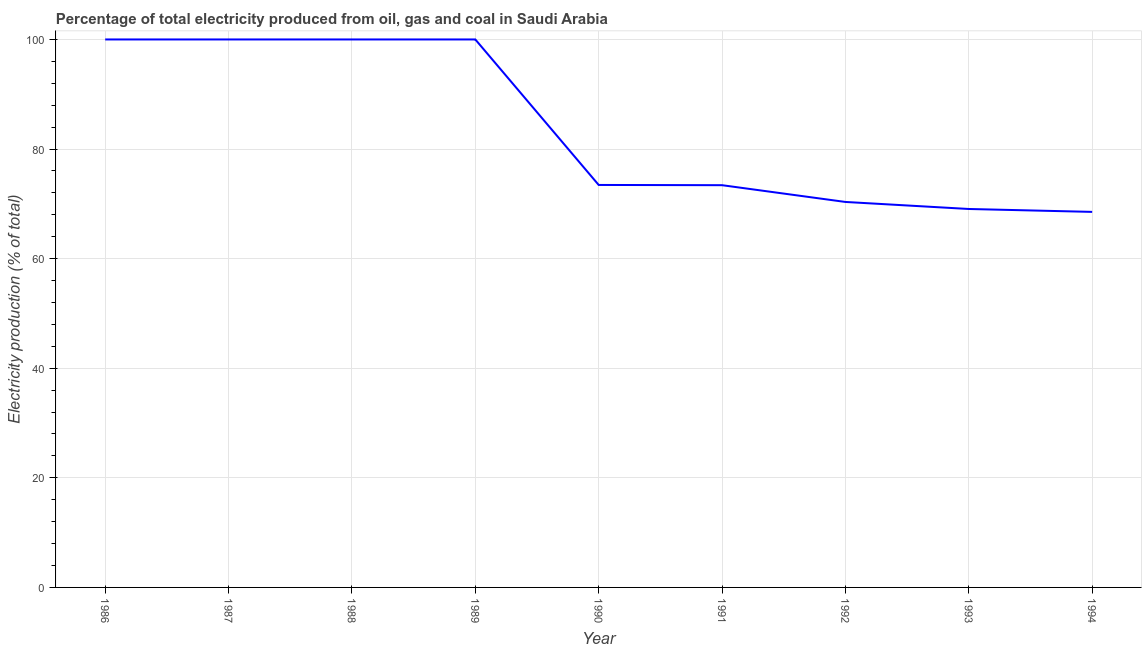What is the electricity production in 1989?
Ensure brevity in your answer.  100. Across all years, what is the maximum electricity production?
Offer a very short reply. 100. Across all years, what is the minimum electricity production?
Keep it short and to the point. 68.53. In which year was the electricity production maximum?
Provide a short and direct response. 1986. In which year was the electricity production minimum?
Provide a short and direct response. 1994. What is the sum of the electricity production?
Your answer should be very brief. 754.79. What is the difference between the electricity production in 1989 and 1993?
Provide a succinct answer. 30.94. What is the average electricity production per year?
Your answer should be very brief. 83.87. What is the median electricity production?
Offer a terse response. 73.45. In how many years, is the electricity production greater than 8 %?
Provide a short and direct response. 9. What is the ratio of the electricity production in 1989 to that in 1991?
Your response must be concise. 1.36. Is the difference between the electricity production in 1987 and 1992 greater than the difference between any two years?
Offer a very short reply. No. What is the difference between the highest and the lowest electricity production?
Your answer should be very brief. 31.47. In how many years, is the electricity production greater than the average electricity production taken over all years?
Offer a very short reply. 4. Does the electricity production monotonically increase over the years?
Ensure brevity in your answer.  No. How many lines are there?
Keep it short and to the point. 1. How many years are there in the graph?
Provide a short and direct response. 9. Does the graph contain any zero values?
Make the answer very short. No. Does the graph contain grids?
Your answer should be compact. Yes. What is the title of the graph?
Make the answer very short. Percentage of total electricity produced from oil, gas and coal in Saudi Arabia. What is the label or title of the Y-axis?
Your answer should be very brief. Electricity production (% of total). What is the Electricity production (% of total) of 1990?
Your answer should be very brief. 73.45. What is the Electricity production (% of total) of 1991?
Provide a short and direct response. 73.4. What is the Electricity production (% of total) in 1992?
Make the answer very short. 70.34. What is the Electricity production (% of total) of 1993?
Provide a short and direct response. 69.06. What is the Electricity production (% of total) of 1994?
Provide a short and direct response. 68.53. What is the difference between the Electricity production (% of total) in 1986 and 1987?
Ensure brevity in your answer.  0. What is the difference between the Electricity production (% of total) in 1986 and 1990?
Keep it short and to the point. 26.55. What is the difference between the Electricity production (% of total) in 1986 and 1991?
Offer a very short reply. 26.6. What is the difference between the Electricity production (% of total) in 1986 and 1992?
Keep it short and to the point. 29.66. What is the difference between the Electricity production (% of total) in 1986 and 1993?
Ensure brevity in your answer.  30.94. What is the difference between the Electricity production (% of total) in 1986 and 1994?
Your answer should be very brief. 31.47. What is the difference between the Electricity production (% of total) in 1987 and 1990?
Your answer should be very brief. 26.55. What is the difference between the Electricity production (% of total) in 1987 and 1991?
Ensure brevity in your answer.  26.6. What is the difference between the Electricity production (% of total) in 1987 and 1992?
Ensure brevity in your answer.  29.66. What is the difference between the Electricity production (% of total) in 1987 and 1993?
Keep it short and to the point. 30.94. What is the difference between the Electricity production (% of total) in 1987 and 1994?
Give a very brief answer. 31.47. What is the difference between the Electricity production (% of total) in 1988 and 1989?
Offer a terse response. 0. What is the difference between the Electricity production (% of total) in 1988 and 1990?
Give a very brief answer. 26.55. What is the difference between the Electricity production (% of total) in 1988 and 1991?
Offer a terse response. 26.6. What is the difference between the Electricity production (% of total) in 1988 and 1992?
Your answer should be very brief. 29.66. What is the difference between the Electricity production (% of total) in 1988 and 1993?
Provide a short and direct response. 30.94. What is the difference between the Electricity production (% of total) in 1988 and 1994?
Give a very brief answer. 31.47. What is the difference between the Electricity production (% of total) in 1989 and 1990?
Keep it short and to the point. 26.55. What is the difference between the Electricity production (% of total) in 1989 and 1991?
Provide a short and direct response. 26.6. What is the difference between the Electricity production (% of total) in 1989 and 1992?
Your answer should be compact. 29.66. What is the difference between the Electricity production (% of total) in 1989 and 1993?
Your answer should be compact. 30.94. What is the difference between the Electricity production (% of total) in 1989 and 1994?
Offer a terse response. 31.47. What is the difference between the Electricity production (% of total) in 1990 and 1991?
Ensure brevity in your answer.  0.04. What is the difference between the Electricity production (% of total) in 1990 and 1992?
Offer a very short reply. 3.1. What is the difference between the Electricity production (% of total) in 1990 and 1993?
Ensure brevity in your answer.  4.39. What is the difference between the Electricity production (% of total) in 1990 and 1994?
Your answer should be compact. 4.92. What is the difference between the Electricity production (% of total) in 1991 and 1992?
Ensure brevity in your answer.  3.06. What is the difference between the Electricity production (% of total) in 1991 and 1993?
Ensure brevity in your answer.  4.34. What is the difference between the Electricity production (% of total) in 1991 and 1994?
Provide a short and direct response. 4.87. What is the difference between the Electricity production (% of total) in 1992 and 1993?
Ensure brevity in your answer.  1.28. What is the difference between the Electricity production (% of total) in 1992 and 1994?
Your answer should be compact. 1.81. What is the difference between the Electricity production (% of total) in 1993 and 1994?
Offer a terse response. 0.53. What is the ratio of the Electricity production (% of total) in 1986 to that in 1987?
Your response must be concise. 1. What is the ratio of the Electricity production (% of total) in 1986 to that in 1989?
Ensure brevity in your answer.  1. What is the ratio of the Electricity production (% of total) in 1986 to that in 1990?
Give a very brief answer. 1.36. What is the ratio of the Electricity production (% of total) in 1986 to that in 1991?
Offer a terse response. 1.36. What is the ratio of the Electricity production (% of total) in 1986 to that in 1992?
Keep it short and to the point. 1.42. What is the ratio of the Electricity production (% of total) in 1986 to that in 1993?
Your answer should be very brief. 1.45. What is the ratio of the Electricity production (% of total) in 1986 to that in 1994?
Ensure brevity in your answer.  1.46. What is the ratio of the Electricity production (% of total) in 1987 to that in 1990?
Offer a terse response. 1.36. What is the ratio of the Electricity production (% of total) in 1987 to that in 1991?
Give a very brief answer. 1.36. What is the ratio of the Electricity production (% of total) in 1987 to that in 1992?
Provide a succinct answer. 1.42. What is the ratio of the Electricity production (% of total) in 1987 to that in 1993?
Make the answer very short. 1.45. What is the ratio of the Electricity production (% of total) in 1987 to that in 1994?
Your answer should be compact. 1.46. What is the ratio of the Electricity production (% of total) in 1988 to that in 1989?
Provide a succinct answer. 1. What is the ratio of the Electricity production (% of total) in 1988 to that in 1990?
Provide a succinct answer. 1.36. What is the ratio of the Electricity production (% of total) in 1988 to that in 1991?
Give a very brief answer. 1.36. What is the ratio of the Electricity production (% of total) in 1988 to that in 1992?
Provide a succinct answer. 1.42. What is the ratio of the Electricity production (% of total) in 1988 to that in 1993?
Keep it short and to the point. 1.45. What is the ratio of the Electricity production (% of total) in 1988 to that in 1994?
Your answer should be compact. 1.46. What is the ratio of the Electricity production (% of total) in 1989 to that in 1990?
Offer a terse response. 1.36. What is the ratio of the Electricity production (% of total) in 1989 to that in 1991?
Provide a short and direct response. 1.36. What is the ratio of the Electricity production (% of total) in 1989 to that in 1992?
Ensure brevity in your answer.  1.42. What is the ratio of the Electricity production (% of total) in 1989 to that in 1993?
Offer a very short reply. 1.45. What is the ratio of the Electricity production (% of total) in 1989 to that in 1994?
Ensure brevity in your answer.  1.46. What is the ratio of the Electricity production (% of total) in 1990 to that in 1991?
Your answer should be very brief. 1. What is the ratio of the Electricity production (% of total) in 1990 to that in 1992?
Give a very brief answer. 1.04. What is the ratio of the Electricity production (% of total) in 1990 to that in 1993?
Give a very brief answer. 1.06. What is the ratio of the Electricity production (% of total) in 1990 to that in 1994?
Provide a short and direct response. 1.07. What is the ratio of the Electricity production (% of total) in 1991 to that in 1992?
Make the answer very short. 1.04. What is the ratio of the Electricity production (% of total) in 1991 to that in 1993?
Offer a terse response. 1.06. What is the ratio of the Electricity production (% of total) in 1991 to that in 1994?
Your answer should be compact. 1.07. What is the ratio of the Electricity production (% of total) in 1992 to that in 1994?
Provide a succinct answer. 1.03. 